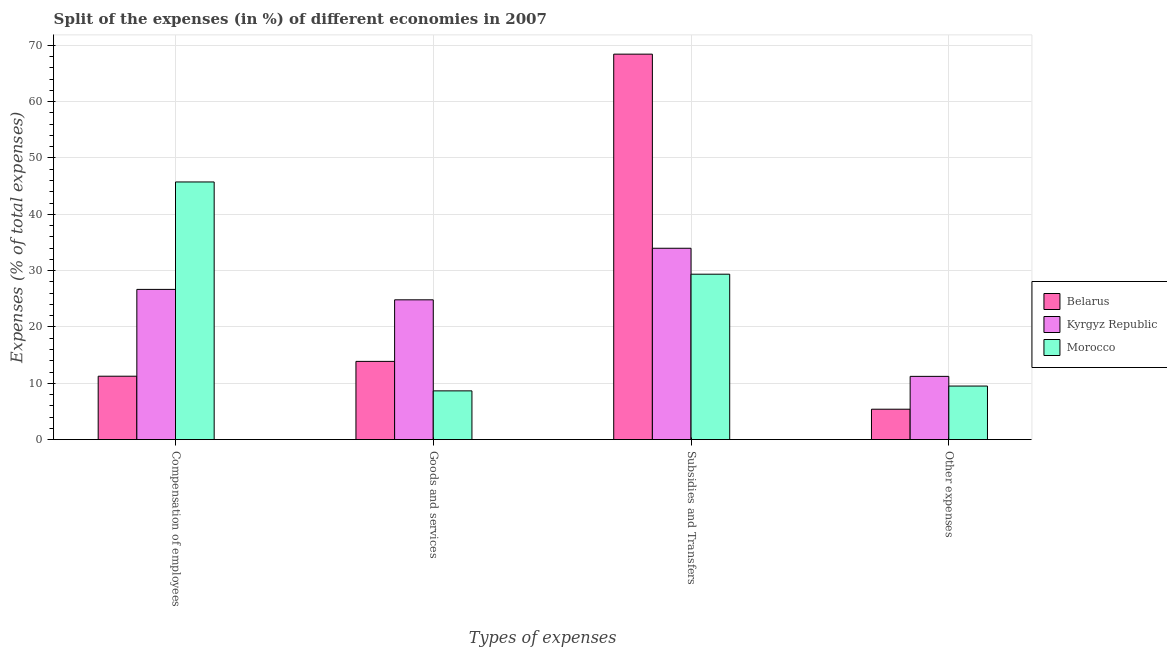Are the number of bars on each tick of the X-axis equal?
Make the answer very short. Yes. How many bars are there on the 3rd tick from the right?
Keep it short and to the point. 3. What is the label of the 4th group of bars from the left?
Keep it short and to the point. Other expenses. What is the percentage of amount spent on subsidies in Kyrgyz Republic?
Ensure brevity in your answer.  33.97. Across all countries, what is the maximum percentage of amount spent on compensation of employees?
Ensure brevity in your answer.  45.75. Across all countries, what is the minimum percentage of amount spent on compensation of employees?
Make the answer very short. 11.26. In which country was the percentage of amount spent on subsidies maximum?
Offer a very short reply. Belarus. In which country was the percentage of amount spent on subsidies minimum?
Provide a short and direct response. Morocco. What is the total percentage of amount spent on other expenses in the graph?
Your response must be concise. 26.13. What is the difference between the percentage of amount spent on other expenses in Belarus and that in Kyrgyz Republic?
Keep it short and to the point. -5.83. What is the difference between the percentage of amount spent on subsidies in Belarus and the percentage of amount spent on other expenses in Morocco?
Keep it short and to the point. 58.93. What is the average percentage of amount spent on other expenses per country?
Ensure brevity in your answer.  8.71. What is the difference between the percentage of amount spent on other expenses and percentage of amount spent on compensation of employees in Belarus?
Keep it short and to the point. -5.86. What is the ratio of the percentage of amount spent on goods and services in Kyrgyz Republic to that in Belarus?
Offer a very short reply. 1.79. Is the difference between the percentage of amount spent on compensation of employees in Belarus and Kyrgyz Republic greater than the difference between the percentage of amount spent on subsidies in Belarus and Kyrgyz Republic?
Provide a short and direct response. No. What is the difference between the highest and the second highest percentage of amount spent on subsidies?
Your answer should be compact. 34.47. What is the difference between the highest and the lowest percentage of amount spent on compensation of employees?
Offer a terse response. 34.49. In how many countries, is the percentage of amount spent on subsidies greater than the average percentage of amount spent on subsidies taken over all countries?
Keep it short and to the point. 1. What does the 1st bar from the left in Subsidies and Transfers represents?
Provide a short and direct response. Belarus. What does the 3rd bar from the right in Goods and services represents?
Your answer should be very brief. Belarus. How many bars are there?
Your answer should be very brief. 12. What is the difference between two consecutive major ticks on the Y-axis?
Your answer should be very brief. 10. Does the graph contain any zero values?
Offer a terse response. No. Does the graph contain grids?
Offer a terse response. Yes. Where does the legend appear in the graph?
Offer a terse response. Center right. How many legend labels are there?
Your response must be concise. 3. How are the legend labels stacked?
Ensure brevity in your answer.  Vertical. What is the title of the graph?
Provide a succinct answer. Split of the expenses (in %) of different economies in 2007. Does "Syrian Arab Republic" appear as one of the legend labels in the graph?
Your answer should be compact. No. What is the label or title of the X-axis?
Provide a succinct answer. Types of expenses. What is the label or title of the Y-axis?
Your response must be concise. Expenses (% of total expenses). What is the Expenses (% of total expenses) of Belarus in Compensation of employees?
Your response must be concise. 11.26. What is the Expenses (% of total expenses) of Kyrgyz Republic in Compensation of employees?
Your answer should be very brief. 26.67. What is the Expenses (% of total expenses) of Morocco in Compensation of employees?
Give a very brief answer. 45.75. What is the Expenses (% of total expenses) of Belarus in Goods and services?
Ensure brevity in your answer.  13.89. What is the Expenses (% of total expenses) of Kyrgyz Republic in Goods and services?
Give a very brief answer. 24.82. What is the Expenses (% of total expenses) of Morocco in Goods and services?
Give a very brief answer. 8.65. What is the Expenses (% of total expenses) of Belarus in Subsidies and Transfers?
Keep it short and to the point. 68.44. What is the Expenses (% of total expenses) in Kyrgyz Republic in Subsidies and Transfers?
Your response must be concise. 33.97. What is the Expenses (% of total expenses) in Morocco in Subsidies and Transfers?
Your answer should be compact. 29.37. What is the Expenses (% of total expenses) in Belarus in Other expenses?
Provide a short and direct response. 5.4. What is the Expenses (% of total expenses) of Kyrgyz Republic in Other expenses?
Your answer should be very brief. 11.23. What is the Expenses (% of total expenses) of Morocco in Other expenses?
Your answer should be compact. 9.51. Across all Types of expenses, what is the maximum Expenses (% of total expenses) in Belarus?
Make the answer very short. 68.44. Across all Types of expenses, what is the maximum Expenses (% of total expenses) in Kyrgyz Republic?
Your answer should be compact. 33.97. Across all Types of expenses, what is the maximum Expenses (% of total expenses) in Morocco?
Offer a terse response. 45.75. Across all Types of expenses, what is the minimum Expenses (% of total expenses) of Belarus?
Provide a succinct answer. 5.4. Across all Types of expenses, what is the minimum Expenses (% of total expenses) of Kyrgyz Republic?
Give a very brief answer. 11.23. Across all Types of expenses, what is the minimum Expenses (% of total expenses) in Morocco?
Give a very brief answer. 8.65. What is the total Expenses (% of total expenses) in Belarus in the graph?
Your answer should be compact. 98.98. What is the total Expenses (% of total expenses) in Kyrgyz Republic in the graph?
Your answer should be very brief. 96.69. What is the total Expenses (% of total expenses) of Morocco in the graph?
Make the answer very short. 93.28. What is the difference between the Expenses (% of total expenses) of Belarus in Compensation of employees and that in Goods and services?
Keep it short and to the point. -2.63. What is the difference between the Expenses (% of total expenses) of Kyrgyz Republic in Compensation of employees and that in Goods and services?
Give a very brief answer. 1.85. What is the difference between the Expenses (% of total expenses) in Morocco in Compensation of employees and that in Goods and services?
Your answer should be compact. 37.09. What is the difference between the Expenses (% of total expenses) of Belarus in Compensation of employees and that in Subsidies and Transfers?
Offer a very short reply. -57.18. What is the difference between the Expenses (% of total expenses) of Kyrgyz Republic in Compensation of employees and that in Subsidies and Transfers?
Your answer should be compact. -7.3. What is the difference between the Expenses (% of total expenses) of Morocco in Compensation of employees and that in Subsidies and Transfers?
Offer a terse response. 16.38. What is the difference between the Expenses (% of total expenses) of Belarus in Compensation of employees and that in Other expenses?
Offer a very short reply. 5.86. What is the difference between the Expenses (% of total expenses) in Kyrgyz Republic in Compensation of employees and that in Other expenses?
Provide a succinct answer. 15.44. What is the difference between the Expenses (% of total expenses) of Morocco in Compensation of employees and that in Other expenses?
Provide a succinct answer. 36.24. What is the difference between the Expenses (% of total expenses) in Belarus in Goods and services and that in Subsidies and Transfers?
Give a very brief answer. -54.55. What is the difference between the Expenses (% of total expenses) in Kyrgyz Republic in Goods and services and that in Subsidies and Transfers?
Offer a very short reply. -9.15. What is the difference between the Expenses (% of total expenses) in Morocco in Goods and services and that in Subsidies and Transfers?
Your answer should be compact. -20.72. What is the difference between the Expenses (% of total expenses) in Belarus in Goods and services and that in Other expenses?
Offer a very short reply. 8.49. What is the difference between the Expenses (% of total expenses) of Kyrgyz Republic in Goods and services and that in Other expenses?
Give a very brief answer. 13.59. What is the difference between the Expenses (% of total expenses) of Morocco in Goods and services and that in Other expenses?
Offer a very short reply. -0.86. What is the difference between the Expenses (% of total expenses) of Belarus in Subsidies and Transfers and that in Other expenses?
Your answer should be compact. 63.04. What is the difference between the Expenses (% of total expenses) in Kyrgyz Republic in Subsidies and Transfers and that in Other expenses?
Make the answer very short. 22.75. What is the difference between the Expenses (% of total expenses) of Morocco in Subsidies and Transfers and that in Other expenses?
Make the answer very short. 19.86. What is the difference between the Expenses (% of total expenses) of Belarus in Compensation of employees and the Expenses (% of total expenses) of Kyrgyz Republic in Goods and services?
Your answer should be very brief. -13.56. What is the difference between the Expenses (% of total expenses) in Belarus in Compensation of employees and the Expenses (% of total expenses) in Morocco in Goods and services?
Offer a very short reply. 2.6. What is the difference between the Expenses (% of total expenses) in Kyrgyz Republic in Compensation of employees and the Expenses (% of total expenses) in Morocco in Goods and services?
Make the answer very short. 18.02. What is the difference between the Expenses (% of total expenses) of Belarus in Compensation of employees and the Expenses (% of total expenses) of Kyrgyz Republic in Subsidies and Transfers?
Give a very brief answer. -22.72. What is the difference between the Expenses (% of total expenses) of Belarus in Compensation of employees and the Expenses (% of total expenses) of Morocco in Subsidies and Transfers?
Offer a very short reply. -18.11. What is the difference between the Expenses (% of total expenses) in Kyrgyz Republic in Compensation of employees and the Expenses (% of total expenses) in Morocco in Subsidies and Transfers?
Offer a very short reply. -2.7. What is the difference between the Expenses (% of total expenses) in Belarus in Compensation of employees and the Expenses (% of total expenses) in Kyrgyz Republic in Other expenses?
Provide a short and direct response. 0.03. What is the difference between the Expenses (% of total expenses) in Belarus in Compensation of employees and the Expenses (% of total expenses) in Morocco in Other expenses?
Provide a short and direct response. 1.75. What is the difference between the Expenses (% of total expenses) of Kyrgyz Republic in Compensation of employees and the Expenses (% of total expenses) of Morocco in Other expenses?
Give a very brief answer. 17.16. What is the difference between the Expenses (% of total expenses) in Belarus in Goods and services and the Expenses (% of total expenses) in Kyrgyz Republic in Subsidies and Transfers?
Your answer should be compact. -20.09. What is the difference between the Expenses (% of total expenses) in Belarus in Goods and services and the Expenses (% of total expenses) in Morocco in Subsidies and Transfers?
Give a very brief answer. -15.48. What is the difference between the Expenses (% of total expenses) of Kyrgyz Republic in Goods and services and the Expenses (% of total expenses) of Morocco in Subsidies and Transfers?
Keep it short and to the point. -4.55. What is the difference between the Expenses (% of total expenses) of Belarus in Goods and services and the Expenses (% of total expenses) of Kyrgyz Republic in Other expenses?
Provide a short and direct response. 2.66. What is the difference between the Expenses (% of total expenses) of Belarus in Goods and services and the Expenses (% of total expenses) of Morocco in Other expenses?
Ensure brevity in your answer.  4.38. What is the difference between the Expenses (% of total expenses) in Kyrgyz Republic in Goods and services and the Expenses (% of total expenses) in Morocco in Other expenses?
Your answer should be compact. 15.31. What is the difference between the Expenses (% of total expenses) in Belarus in Subsidies and Transfers and the Expenses (% of total expenses) in Kyrgyz Republic in Other expenses?
Offer a terse response. 57.21. What is the difference between the Expenses (% of total expenses) in Belarus in Subsidies and Transfers and the Expenses (% of total expenses) in Morocco in Other expenses?
Provide a succinct answer. 58.93. What is the difference between the Expenses (% of total expenses) in Kyrgyz Republic in Subsidies and Transfers and the Expenses (% of total expenses) in Morocco in Other expenses?
Keep it short and to the point. 24.47. What is the average Expenses (% of total expenses) in Belarus per Types of expenses?
Your response must be concise. 24.74. What is the average Expenses (% of total expenses) of Kyrgyz Republic per Types of expenses?
Offer a very short reply. 24.17. What is the average Expenses (% of total expenses) in Morocco per Types of expenses?
Provide a succinct answer. 23.32. What is the difference between the Expenses (% of total expenses) in Belarus and Expenses (% of total expenses) in Kyrgyz Republic in Compensation of employees?
Ensure brevity in your answer.  -15.41. What is the difference between the Expenses (% of total expenses) of Belarus and Expenses (% of total expenses) of Morocco in Compensation of employees?
Offer a terse response. -34.49. What is the difference between the Expenses (% of total expenses) of Kyrgyz Republic and Expenses (% of total expenses) of Morocco in Compensation of employees?
Your answer should be very brief. -19.08. What is the difference between the Expenses (% of total expenses) in Belarus and Expenses (% of total expenses) in Kyrgyz Republic in Goods and services?
Your answer should be compact. -10.93. What is the difference between the Expenses (% of total expenses) of Belarus and Expenses (% of total expenses) of Morocco in Goods and services?
Your answer should be very brief. 5.23. What is the difference between the Expenses (% of total expenses) in Kyrgyz Republic and Expenses (% of total expenses) in Morocco in Goods and services?
Offer a terse response. 16.17. What is the difference between the Expenses (% of total expenses) of Belarus and Expenses (% of total expenses) of Kyrgyz Republic in Subsidies and Transfers?
Make the answer very short. 34.47. What is the difference between the Expenses (% of total expenses) in Belarus and Expenses (% of total expenses) in Morocco in Subsidies and Transfers?
Give a very brief answer. 39.07. What is the difference between the Expenses (% of total expenses) of Kyrgyz Republic and Expenses (% of total expenses) of Morocco in Subsidies and Transfers?
Offer a very short reply. 4.6. What is the difference between the Expenses (% of total expenses) in Belarus and Expenses (% of total expenses) in Kyrgyz Republic in Other expenses?
Your answer should be compact. -5.83. What is the difference between the Expenses (% of total expenses) of Belarus and Expenses (% of total expenses) of Morocco in Other expenses?
Provide a succinct answer. -4.11. What is the difference between the Expenses (% of total expenses) in Kyrgyz Republic and Expenses (% of total expenses) in Morocco in Other expenses?
Your answer should be compact. 1.72. What is the ratio of the Expenses (% of total expenses) of Belarus in Compensation of employees to that in Goods and services?
Make the answer very short. 0.81. What is the ratio of the Expenses (% of total expenses) of Kyrgyz Republic in Compensation of employees to that in Goods and services?
Ensure brevity in your answer.  1.07. What is the ratio of the Expenses (% of total expenses) in Morocco in Compensation of employees to that in Goods and services?
Your response must be concise. 5.29. What is the ratio of the Expenses (% of total expenses) in Belarus in Compensation of employees to that in Subsidies and Transfers?
Your response must be concise. 0.16. What is the ratio of the Expenses (% of total expenses) in Kyrgyz Republic in Compensation of employees to that in Subsidies and Transfers?
Offer a very short reply. 0.79. What is the ratio of the Expenses (% of total expenses) in Morocco in Compensation of employees to that in Subsidies and Transfers?
Make the answer very short. 1.56. What is the ratio of the Expenses (% of total expenses) in Belarus in Compensation of employees to that in Other expenses?
Provide a succinct answer. 2.09. What is the ratio of the Expenses (% of total expenses) of Kyrgyz Republic in Compensation of employees to that in Other expenses?
Offer a terse response. 2.38. What is the ratio of the Expenses (% of total expenses) in Morocco in Compensation of employees to that in Other expenses?
Give a very brief answer. 4.81. What is the ratio of the Expenses (% of total expenses) in Belarus in Goods and services to that in Subsidies and Transfers?
Offer a terse response. 0.2. What is the ratio of the Expenses (% of total expenses) of Kyrgyz Republic in Goods and services to that in Subsidies and Transfers?
Your answer should be very brief. 0.73. What is the ratio of the Expenses (% of total expenses) of Morocco in Goods and services to that in Subsidies and Transfers?
Give a very brief answer. 0.29. What is the ratio of the Expenses (% of total expenses) in Belarus in Goods and services to that in Other expenses?
Your answer should be compact. 2.57. What is the ratio of the Expenses (% of total expenses) in Kyrgyz Republic in Goods and services to that in Other expenses?
Your answer should be very brief. 2.21. What is the ratio of the Expenses (% of total expenses) in Morocco in Goods and services to that in Other expenses?
Your answer should be very brief. 0.91. What is the ratio of the Expenses (% of total expenses) in Belarus in Subsidies and Transfers to that in Other expenses?
Your response must be concise. 12.68. What is the ratio of the Expenses (% of total expenses) in Kyrgyz Republic in Subsidies and Transfers to that in Other expenses?
Make the answer very short. 3.03. What is the ratio of the Expenses (% of total expenses) in Morocco in Subsidies and Transfers to that in Other expenses?
Provide a succinct answer. 3.09. What is the difference between the highest and the second highest Expenses (% of total expenses) in Belarus?
Provide a succinct answer. 54.55. What is the difference between the highest and the second highest Expenses (% of total expenses) in Kyrgyz Republic?
Make the answer very short. 7.3. What is the difference between the highest and the second highest Expenses (% of total expenses) in Morocco?
Your response must be concise. 16.38. What is the difference between the highest and the lowest Expenses (% of total expenses) of Belarus?
Your answer should be compact. 63.04. What is the difference between the highest and the lowest Expenses (% of total expenses) of Kyrgyz Republic?
Your response must be concise. 22.75. What is the difference between the highest and the lowest Expenses (% of total expenses) of Morocco?
Your answer should be very brief. 37.09. 